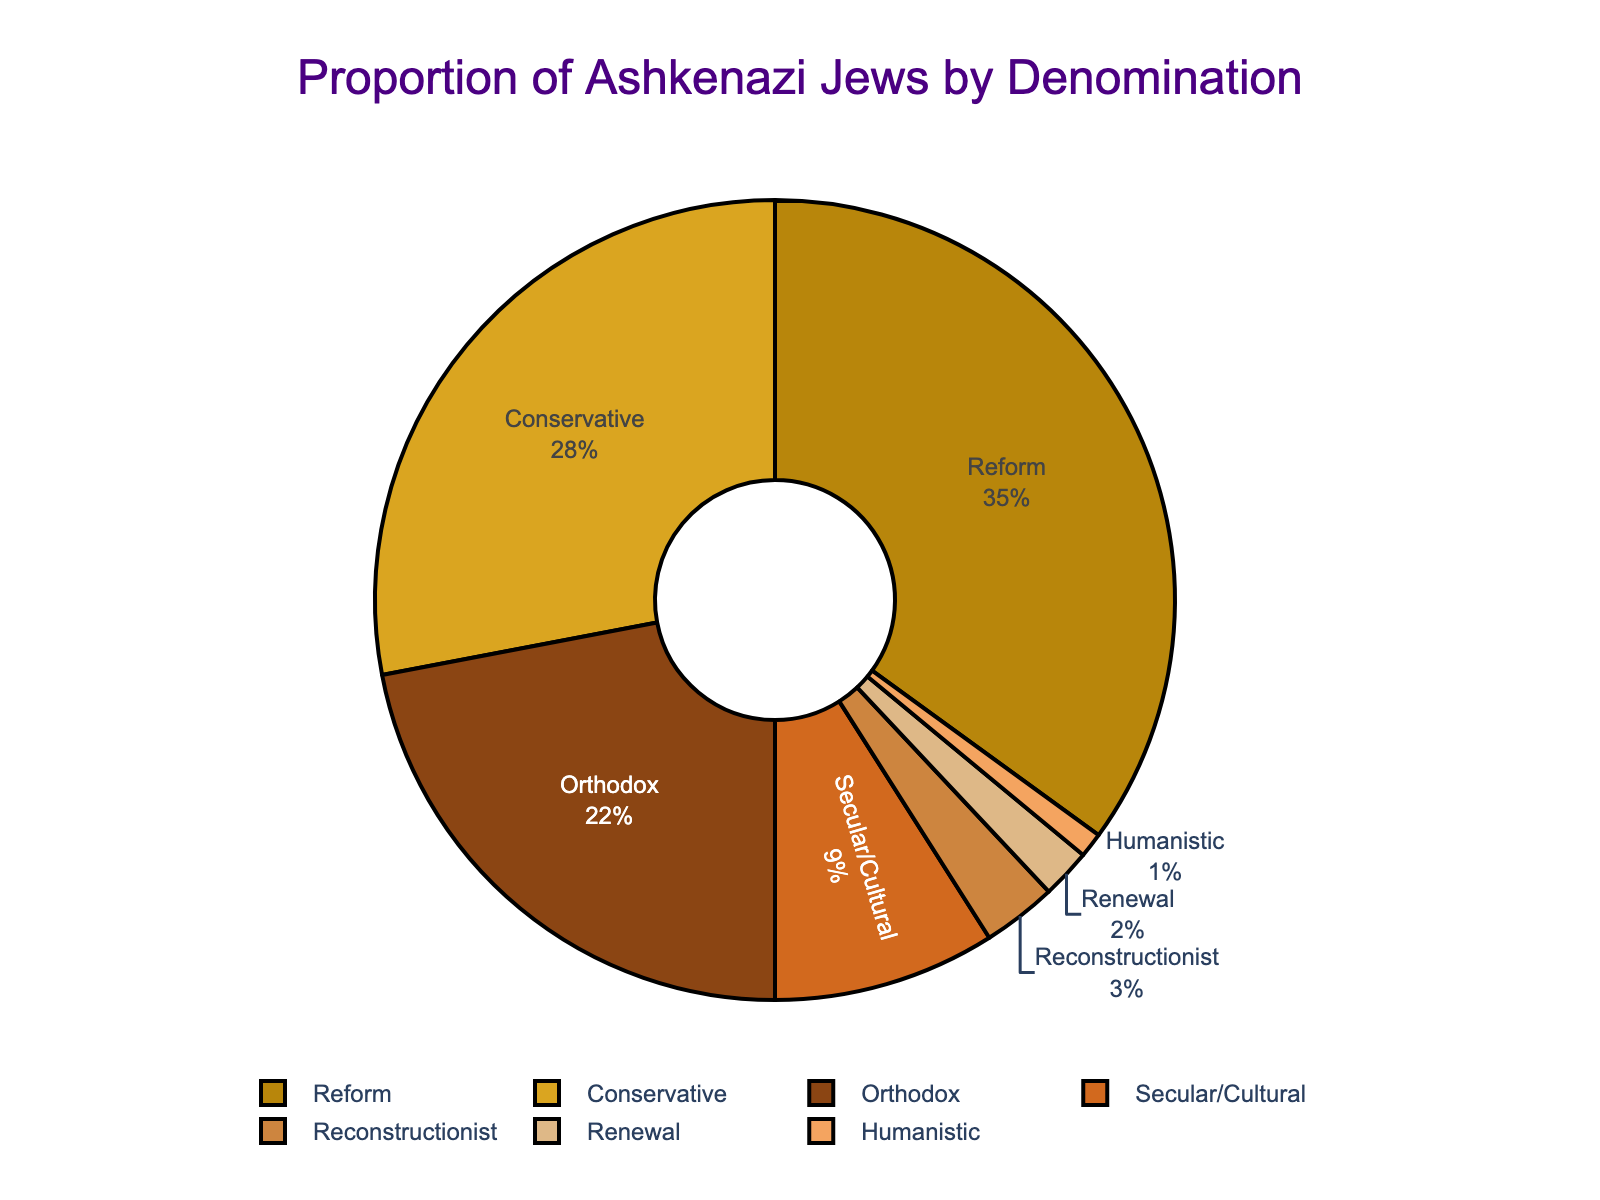What percentage of Ashkenazi Jews identify as Reform? Reform Jews are represented as one section of the pie chart, which is labeled with its specific percentage.
Answer: 35% Which denomination has the smallest percentage of Ashkenazi Jews? By visually examining the pie chart, we observe that Humanistic has the smallest slice, which is labeled with its percentage.
Answer: Humanistic What is the combined percentage of Ashkenazi Jews who identify as Orthodox and Conservative? Add the percentages of Orthodox (22%) and Conservative (28%) denominations. Thus, 22 + 28 = 50.
Answer: 50% How much larger is the percentage of Ashkenazi Jews identifying as Reform compared to those identifying as Orthodox? Subtract the percentage of Orthodox (22%) from the percentage of Reform (35%). Thus, 35 - 22 = 13.
Answer: 13% Which two denominations together account for more than half of the Ashkenazi Jewish population in the chart? Sum the percentages of different pairs and find the combination greater than 50%. Orthodox plus Conservative equals 50%, but Reform plus Conservative equals 35% + 28% = 63%.
Answer: Reform and Conservative What visual attribute indicates the proportion of Ashkenazi Jews who identify as Renewal? The Renewal denomination is represented by a particular color in the pie chart. We identify Renewal by the color of the corresponding slice labeled with its percentage.
Answer: A specific color slice labeled 2% Which has a higher percentage: Ashkenazi Jews identifying as Secular/Cultural or those identifying as Reconstructionist? Compare the percentage slices for Secular/Cultural (9%) with Reconstructionist (3%).
Answer: Secular/Cultural What is the total proportion of Ashkenazi Jews who do not identify with the top three largest denominations (Orthodox, Conservative, Reform)? Calculate the sum of percentages for denominations not in the top three: Reconstructionist (3%), Secular/Cultural (9%), Renewal (2%), Humanistic (1%). The sum is 3 + 9 + 2 + 1 = 15.
Answer: 15% If the percentage of Reform Jews increased by 5%, what would their new percentage be? Add 5% to the existing percentage of Reform Jews: 35 + 5 = 40.
Answer: 40% Is the total percentage of Ashkenazi Jews identifying with Orthodox and Conservative combined less than those identifying with Reform? Sum the percentages of Orthodox (22%) and Conservative (28%) and compare with Reform (35%). So, 22 + 28 = 50, which is greater than 35.
Answer: No 